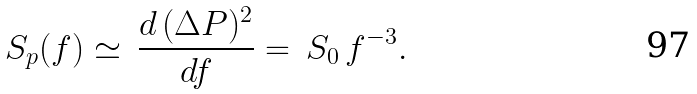<formula> <loc_0><loc_0><loc_500><loc_500>S _ { p } ( f ) \simeq \, \frac { d \, ( \Delta P ) ^ { 2 } } { d f } = \, S _ { 0 } \, f ^ { - 3 } .</formula> 